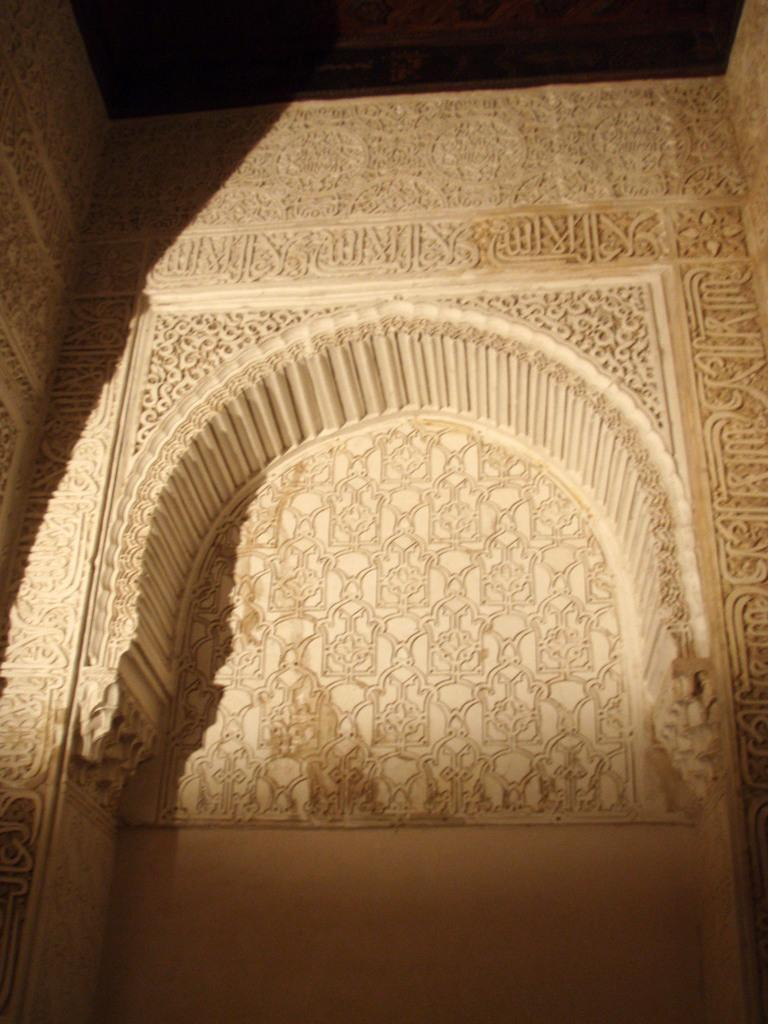Where was the image most likely taken? The image was likely taken indoors. What can be seen in the center of the image? There is a wall of a building in the center of the image. What architectural feature is present on the wall? There is an arch on the wall. What is written on the wall? Text is written on the wall. How many oranges are placed on the sofa in the image? There are no oranges or sofa present in the image. What type of sail can be seen in the image? There is no sail present in the image. 